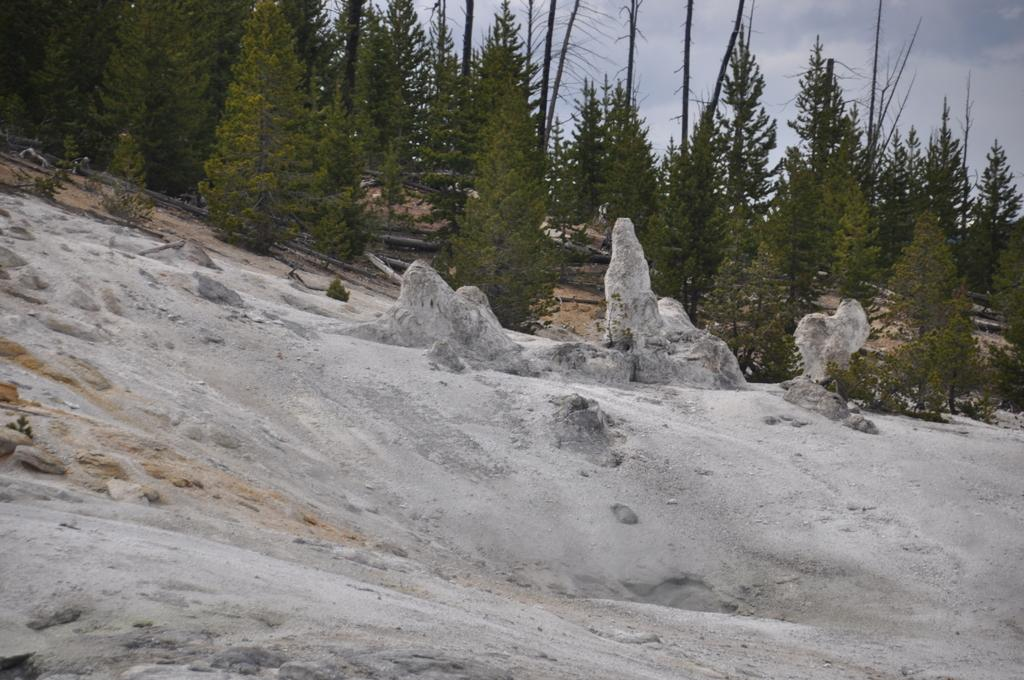What type of natural elements can be seen in the image? There are rocks and sand visible in the image. What can be seen in the background of the image? There are trees and the sky visible in the background of the image. Where is the table located in the image? There is no table present in the image. What type of berry can be seen growing on the trees in the image? There are no berries visible on the trees in the image. 